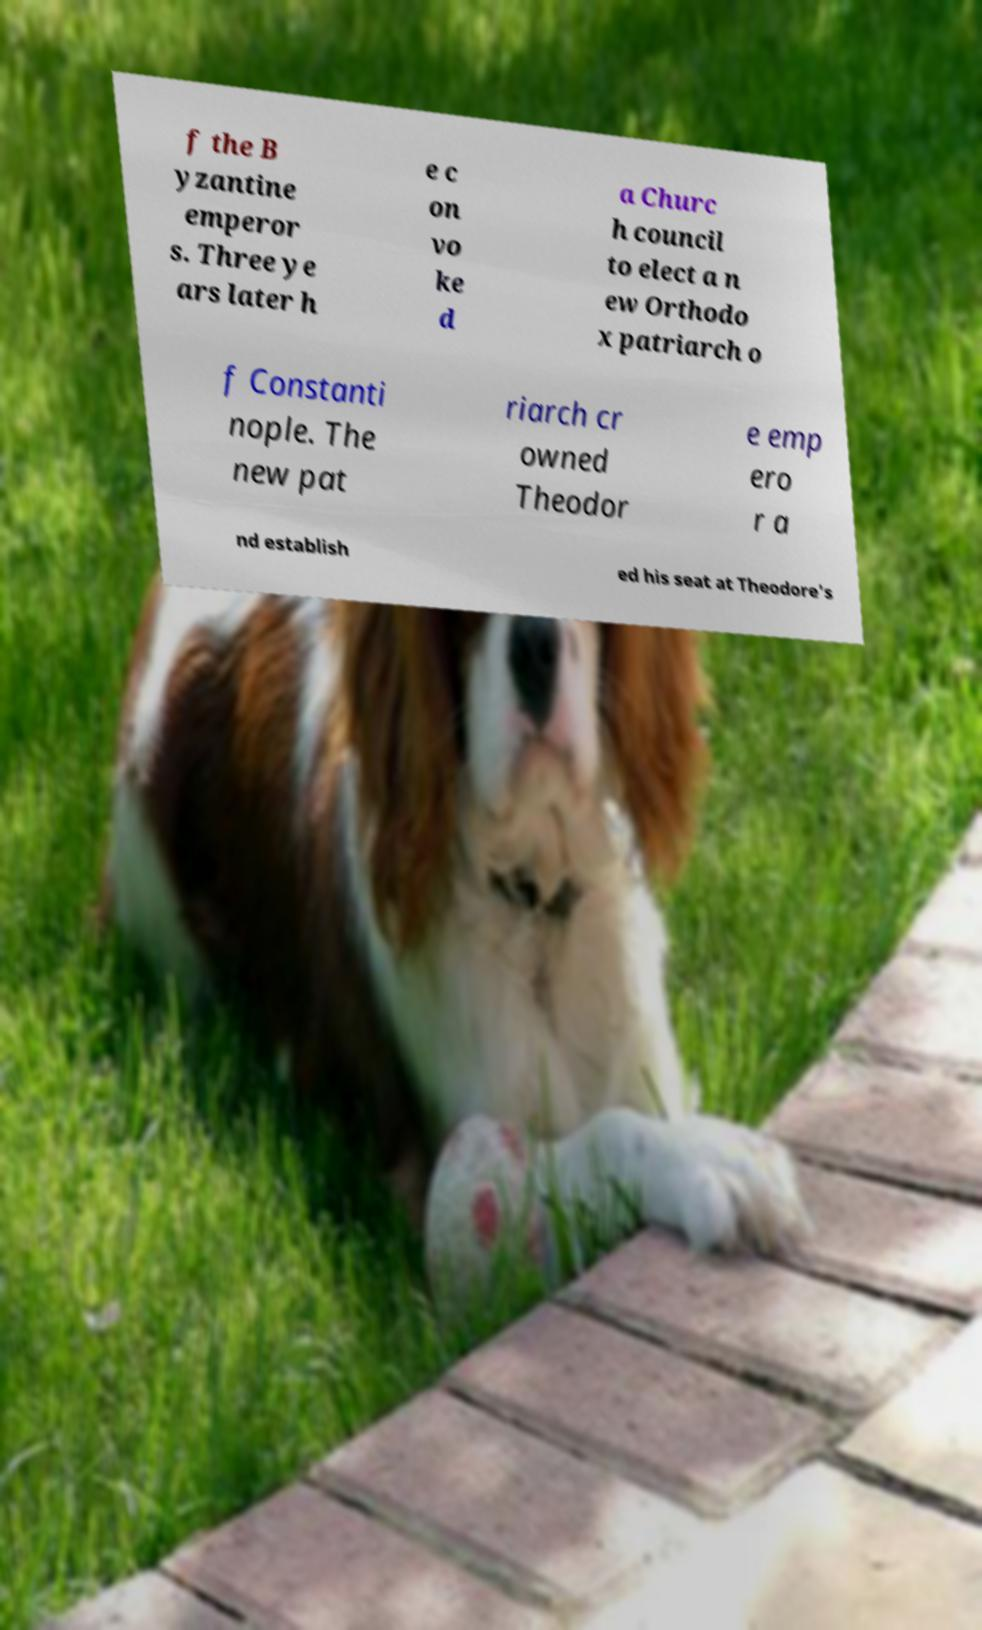Please identify and transcribe the text found in this image. f the B yzantine emperor s. Three ye ars later h e c on vo ke d a Churc h council to elect a n ew Orthodo x patriarch o f Constanti nople. The new pat riarch cr owned Theodor e emp ero r a nd establish ed his seat at Theodore's 